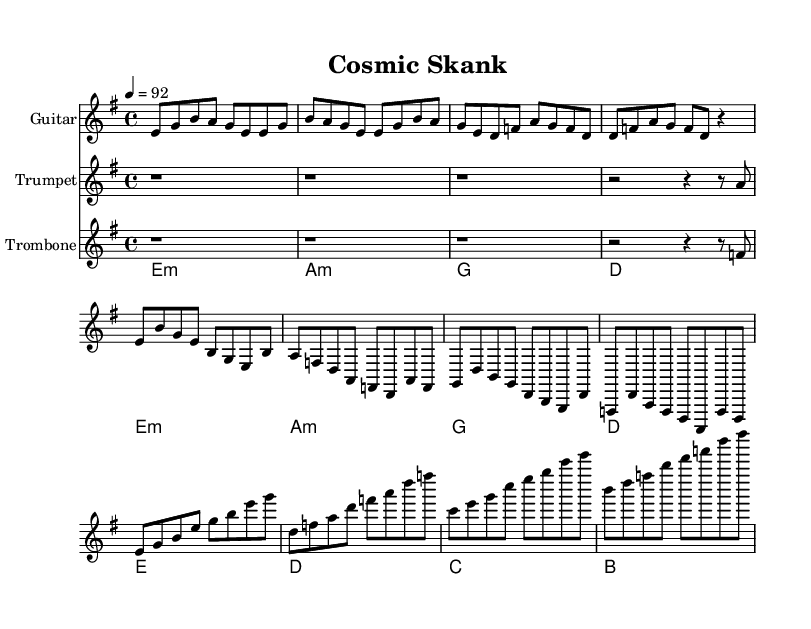What is the key signature of this music? The key signature is identified at the beginning of the score and shows two sharps, indicating that the music is in E minor.
Answer: E minor What is the time signature of this music? The time signature is indicated in the upper left section of the score, showing 4/4, which means there are four beats in a measure.
Answer: 4/4 What is the tempo marking in this score? The tempo marking is found near the beginning of the score, stating "4 = 92," which indicates that the quarter note receives a speed of 92 beats per minute.
Answer: 92 How many measures are in the guitar part of the score? By counting the measures in the guitarIntro, guitarVerse, and guitarChorus sections, we find there are a total of 12 measures in the guitar part.
Answer: 12 Which instruments are featured in this composition? The instruments are listed at the beginning of each staff in the score; they include Guitar, Trumpet, and Trombone.
Answer: Guitar, Trumpet, Trombone What chord is played at the beginning of the second measure in the guitar section? The chord is indicated in the ChordNames section, where the second measure corresponds to the A minor chord, derived from the harmonic structure of the piece.
Answer: A minor What does the use of rests in the trumpet and trombone sections signify? The rests in the trumpet and trombone sections indicate that these instruments are not playing during those beats, allowing for a space in the rhythm and adding to the overall texture of the music.
Answer: Silence 